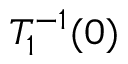<formula> <loc_0><loc_0><loc_500><loc_500>T _ { 1 } ^ { - 1 } ( 0 )</formula> 